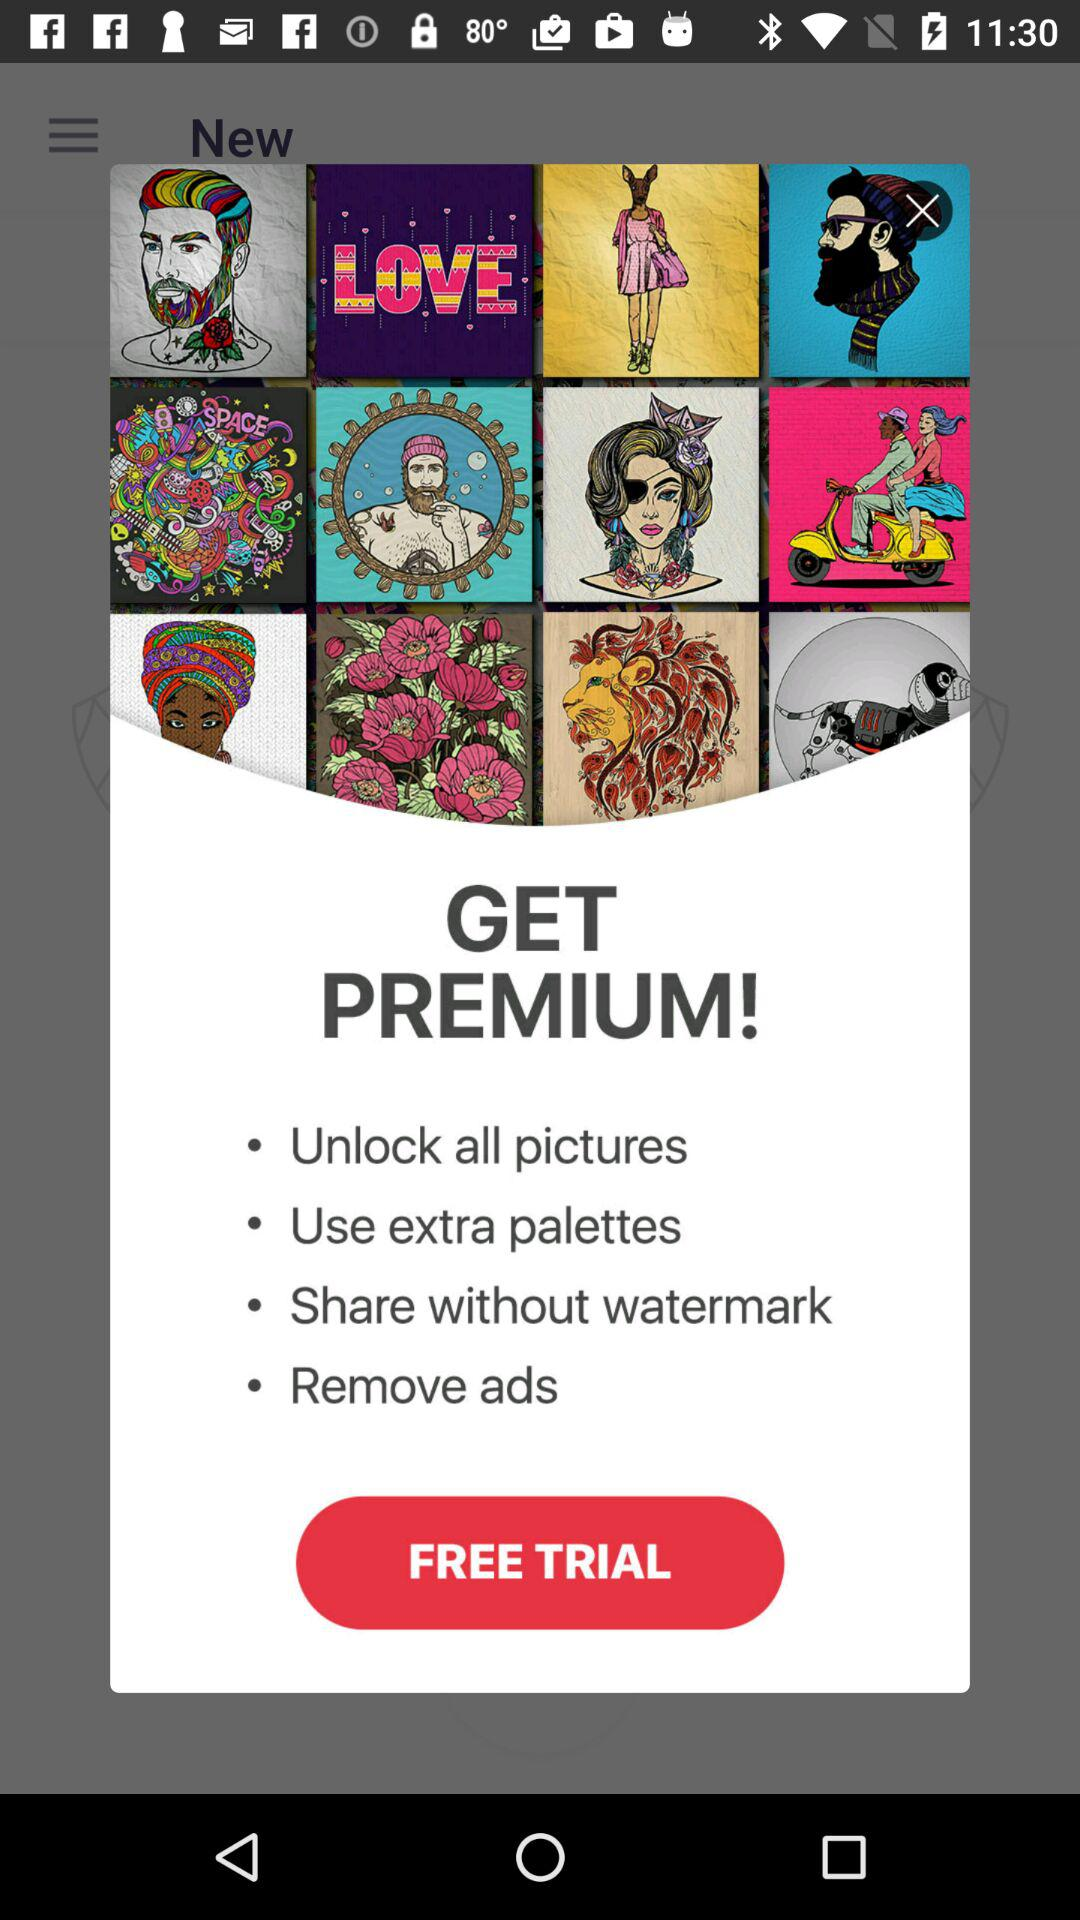Is the trial free or paid? The trial is free. 